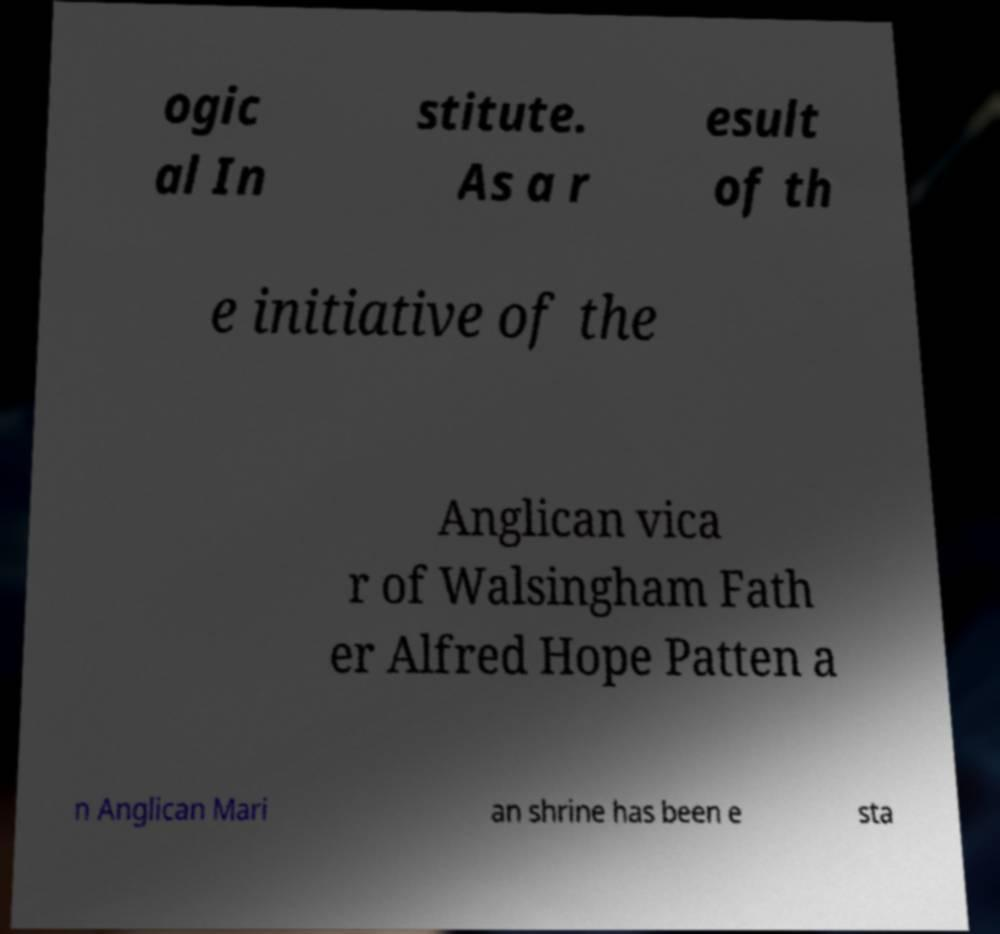What messages or text are displayed in this image? I need them in a readable, typed format. ogic al In stitute. As a r esult of th e initiative of the Anglican vica r of Walsingham Fath er Alfred Hope Patten a n Anglican Mari an shrine has been e sta 